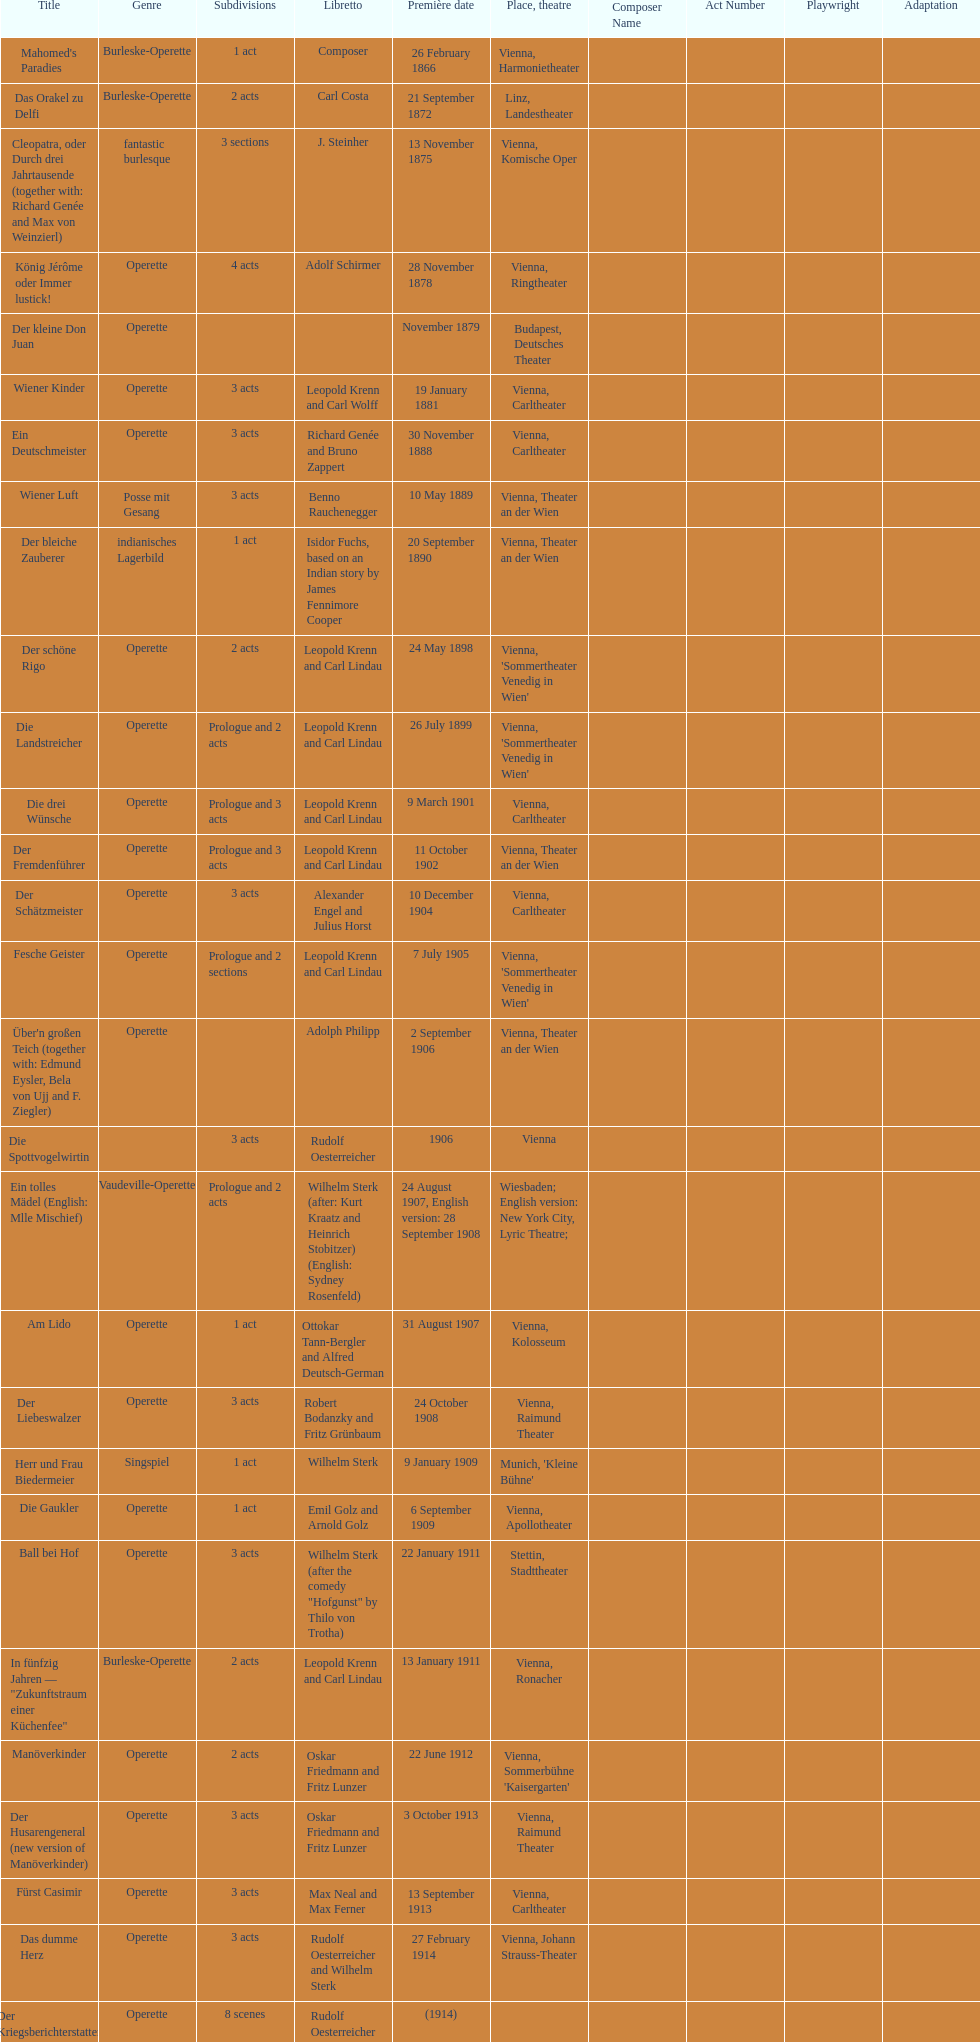What is the quantity of 1 acts that occurred? 5. 